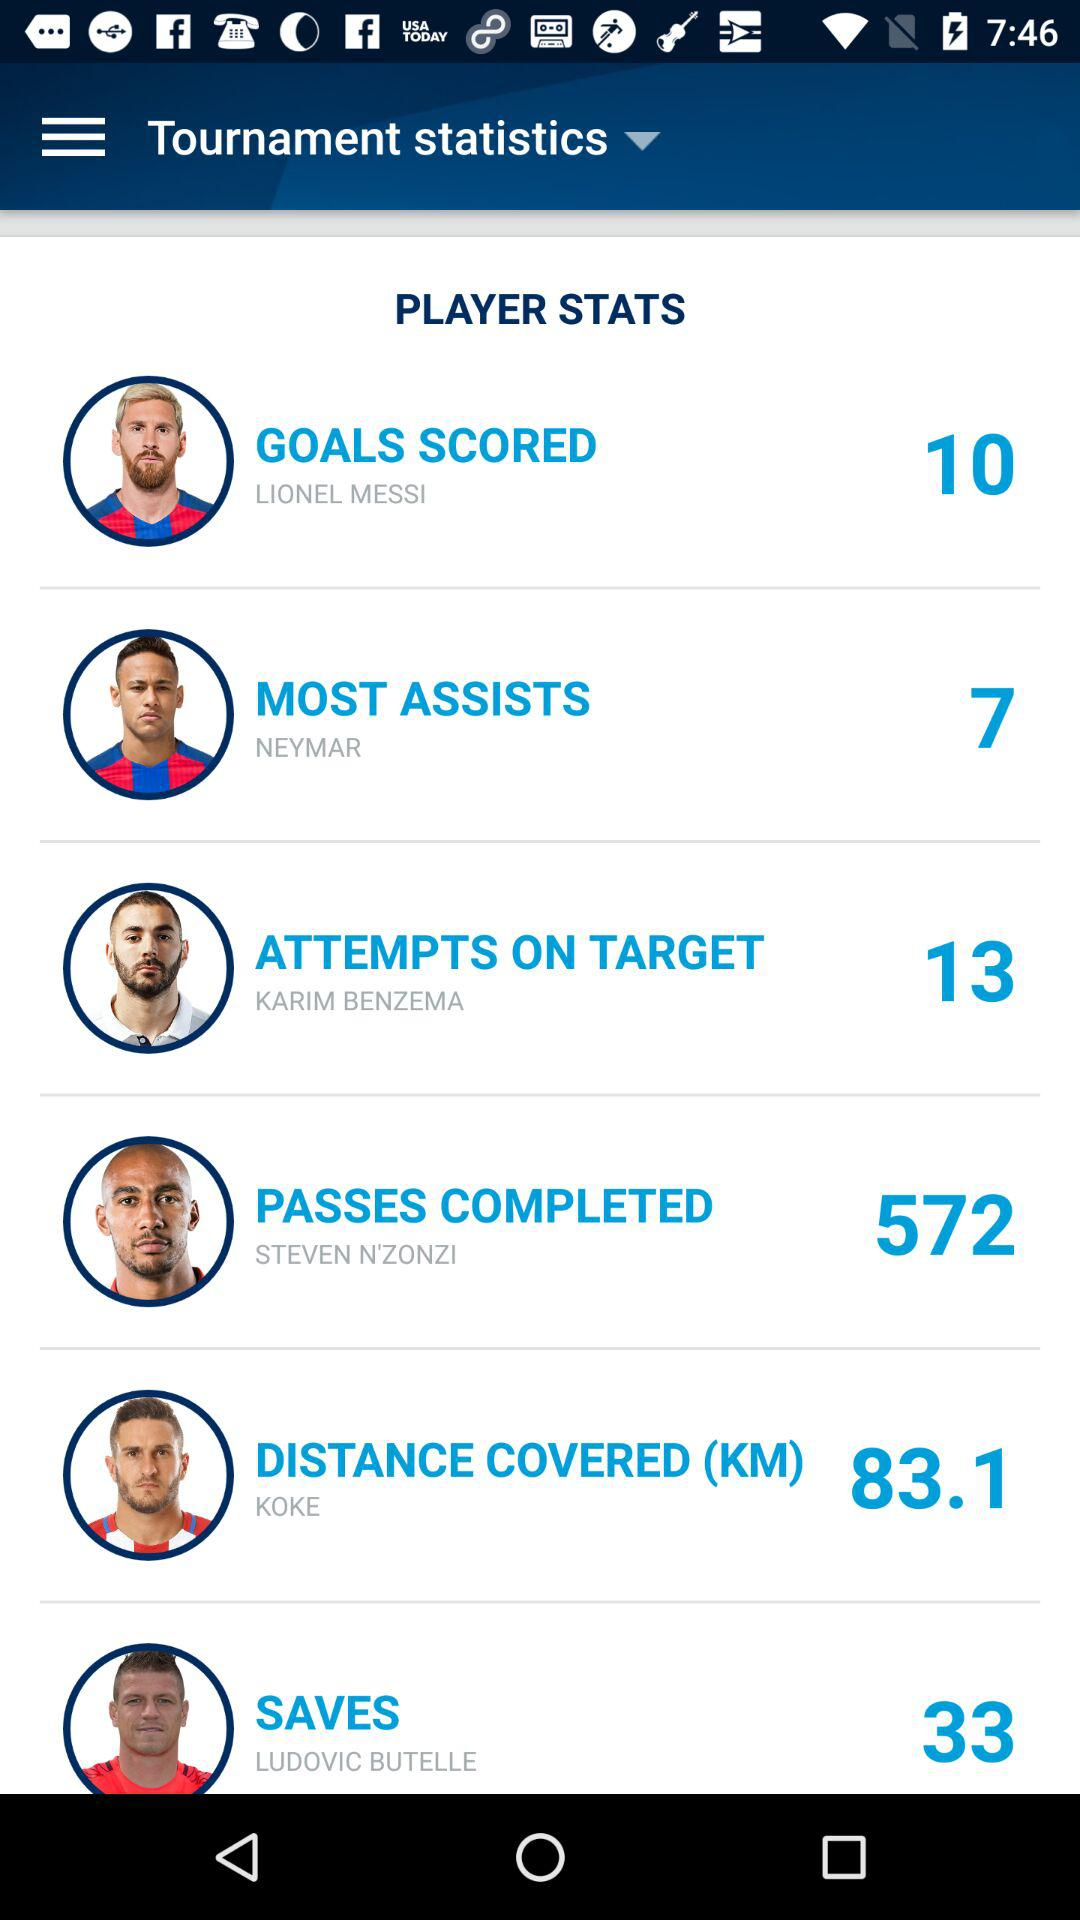How many goals were saved by Ludovic Butelle? Ludovic Butelle saved 33 goals. 